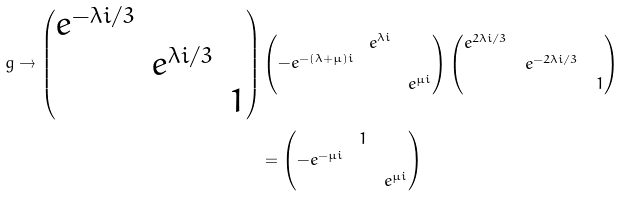Convert formula to latex. <formula><loc_0><loc_0><loc_500><loc_500>g \to \begin{pmatrix} e ^ { - \lambda i / 3 } & & \\ & e ^ { \lambda i / 3 } & \\ & & 1 \end{pmatrix} & \begin{pmatrix} & e ^ { \lambda i } & \\ - e ^ { - ( \lambda + \mu ) i } & & \\ & & e ^ { \mu i } \end{pmatrix} \begin{pmatrix} e ^ { 2 \lambda i / 3 } & & \\ & e ^ { - 2 \lambda i / 3 } & \\ & & 1 \end{pmatrix} \\ & = \begin{pmatrix} & 1 & \\ - e ^ { - \mu i } & & \\ & & e ^ { \mu i } \end{pmatrix}</formula> 